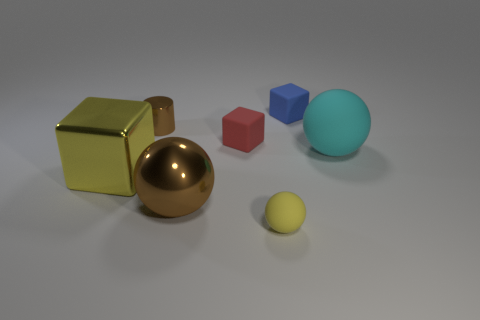There is a rubber thing that is behind the tiny brown cylinder that is behind the big yellow object; what size is it?
Your answer should be very brief. Small. How many matte cylinders have the same size as the red cube?
Make the answer very short. 0. Does the tiny block to the left of the tiny blue matte object have the same color as the rubber object in front of the cyan matte thing?
Ensure brevity in your answer.  No. Are there any big shiny blocks in front of the large yellow thing?
Offer a terse response. No. What is the color of the metallic thing that is to the right of the large yellow block and on the left side of the big brown ball?
Offer a very short reply. Brown. Is there a tiny sphere of the same color as the large cube?
Provide a succinct answer. Yes. Does the yellow thing that is on the right side of the small red cube have the same material as the tiny object that is right of the yellow matte sphere?
Provide a succinct answer. Yes. What is the size of the rubber object that is behind the small cylinder?
Your response must be concise. Small. The blue rubber cube is what size?
Offer a terse response. Small. How big is the ball that is to the right of the matte block that is behind the small rubber cube in front of the small brown cylinder?
Provide a succinct answer. Large. 